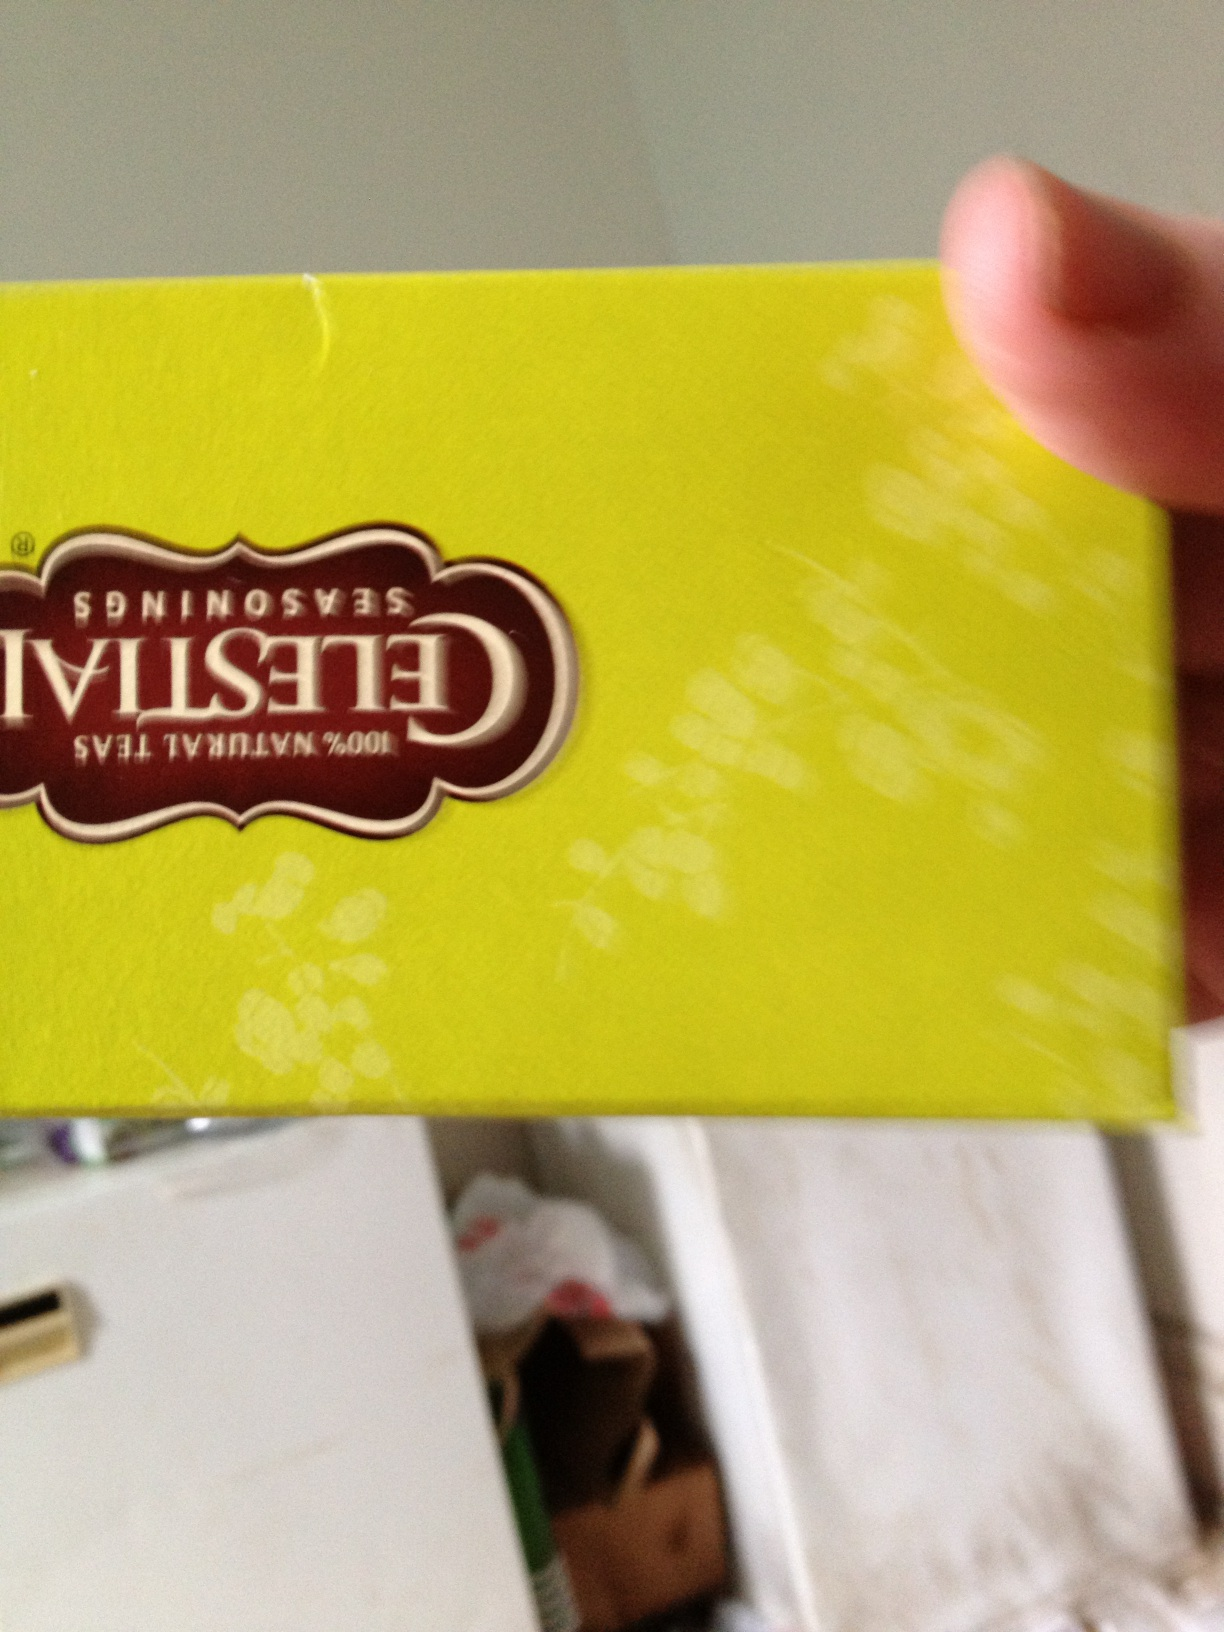Can you tell me more about the brand that makes this tea? Celestial Seasonings is a renowned tea company known for producing an extensive range of herbal, green, and black teas. Established in the 1970s, the brand prides itself on creating flavorful and aromatic teas using high-quality, natural ingredients. Their products are often packaged in colorful and artistic boxes, making them distinct and recognizable. I see some flowers on the packaging. What's special about them? The flowers depicted on the packaging often represent the natural ingredients used in the tea blend. Celestial Seasonings is known for incorporating a variety of herbs, spices, and flowers such as chamomile, hibiscus, and lavender to create unique and soothing tea blends. The floral imagery not only adds an aesthetic appeal but also hints at the natural and botanical essence of the tea inside. Why might someone choose Celestial Seasonings over another tea brand? Choosing Celestial Seasonings can be attributed to several factors. The brand has a reputation for using high-quality, organic, and natural ingredients, which appeals to health-conscious consumers. Additionally, they offer a wide variety of flavors and innovative blends that cater to different tastes and preferences. Their commitment to sustainability and eco-friendly practices also draws environmentally-conscious consumers. The colorful and artistic packaging adds to its appeal, making it a favorite for both taste and visual delight. Can you imagine an enchanted forest where the plants are tea herbs? What would it be like? Imagine entering an enchanted forest where the air is filled with the soothing aromas of chamomile, mint, and hibiscus. The trees are majestic tea plants, with leaves shimmering in the sunlight, beckoning you to explore. The ground is carpeted with a vibrant tapestry of flowers, each representing a different tea herb—lavender, rose petals, and lemon balm. Streams of clear, crystal water run through the forest, infused with the natural essence of green tea, offering a refreshing sip to any traveler. Birds with wings made of tea leaves flutter around, singing harmonious melodies that resonate through the forest. A peaceful aura envelops you as you walk further, feeling the calming energy of the herbal blends. This is a magical place where the essence of every tea blend breathes life into the surroundings, creating an atmosphere of tranquility and wonder. 